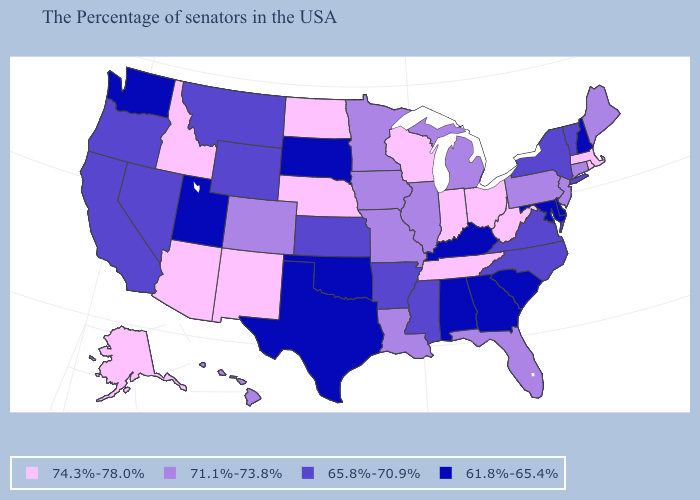Among the states that border Arkansas , which have the highest value?
Write a very short answer. Tennessee. Name the states that have a value in the range 71.1%-73.8%?
Give a very brief answer. Maine, Connecticut, New Jersey, Pennsylvania, Florida, Michigan, Illinois, Louisiana, Missouri, Minnesota, Iowa, Colorado, Hawaii. Among the states that border Rhode Island , which have the highest value?
Concise answer only. Massachusetts. What is the value of Texas?
Give a very brief answer. 61.8%-65.4%. How many symbols are there in the legend?
Quick response, please. 4. Which states hav the highest value in the Northeast?
Answer briefly. Massachusetts, Rhode Island. What is the lowest value in states that border Kentucky?
Quick response, please. 65.8%-70.9%. Among the states that border North Carolina , which have the lowest value?
Be succinct. South Carolina, Georgia. Which states hav the highest value in the MidWest?
Be succinct. Ohio, Indiana, Wisconsin, Nebraska, North Dakota. Does Missouri have the highest value in the MidWest?
Be succinct. No. What is the value of Hawaii?
Write a very short answer. 71.1%-73.8%. What is the highest value in the USA?
Answer briefly. 74.3%-78.0%. Does the first symbol in the legend represent the smallest category?
Give a very brief answer. No. Does the first symbol in the legend represent the smallest category?
Give a very brief answer. No. Which states have the highest value in the USA?
Write a very short answer. Massachusetts, Rhode Island, West Virginia, Ohio, Indiana, Tennessee, Wisconsin, Nebraska, North Dakota, New Mexico, Arizona, Idaho, Alaska. 